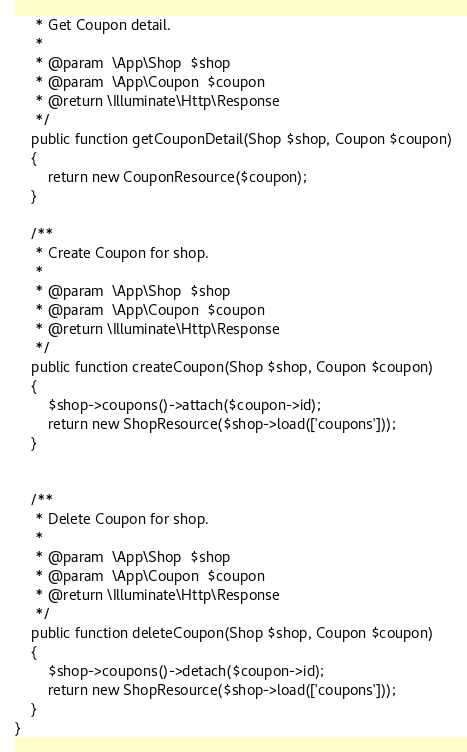<code> <loc_0><loc_0><loc_500><loc_500><_PHP_>     * Get Coupon detail.
     *
     * @param  \App\Shop  $shop
     * @param  \App\Coupon  $coupon
     * @return \Illuminate\Http\Response
     */
    public function getCouponDetail(Shop $shop, Coupon $coupon)
    {
        return new CouponResource($coupon);
    }

    /**
     * Create Coupon for shop.
     *
     * @param  \App\Shop  $shop
     * @param  \App\Coupon  $coupon
     * @return \Illuminate\Http\Response
     */
    public function createCoupon(Shop $shop, Coupon $coupon)
    {
        $shop->coupons()->attach($coupon->id);
        return new ShopResource($shop->load(['coupons']));
    }


    /**
     * Delete Coupon for shop.
     *
     * @param  \App\Shop  $shop
     * @param  \App\Coupon  $coupon
     * @return \Illuminate\Http\Response
     */
    public function deleteCoupon(Shop $shop, Coupon $coupon)
    {
        $shop->coupons()->detach($coupon->id);
        return new ShopResource($shop->load(['coupons']));
    }
}
</code> 